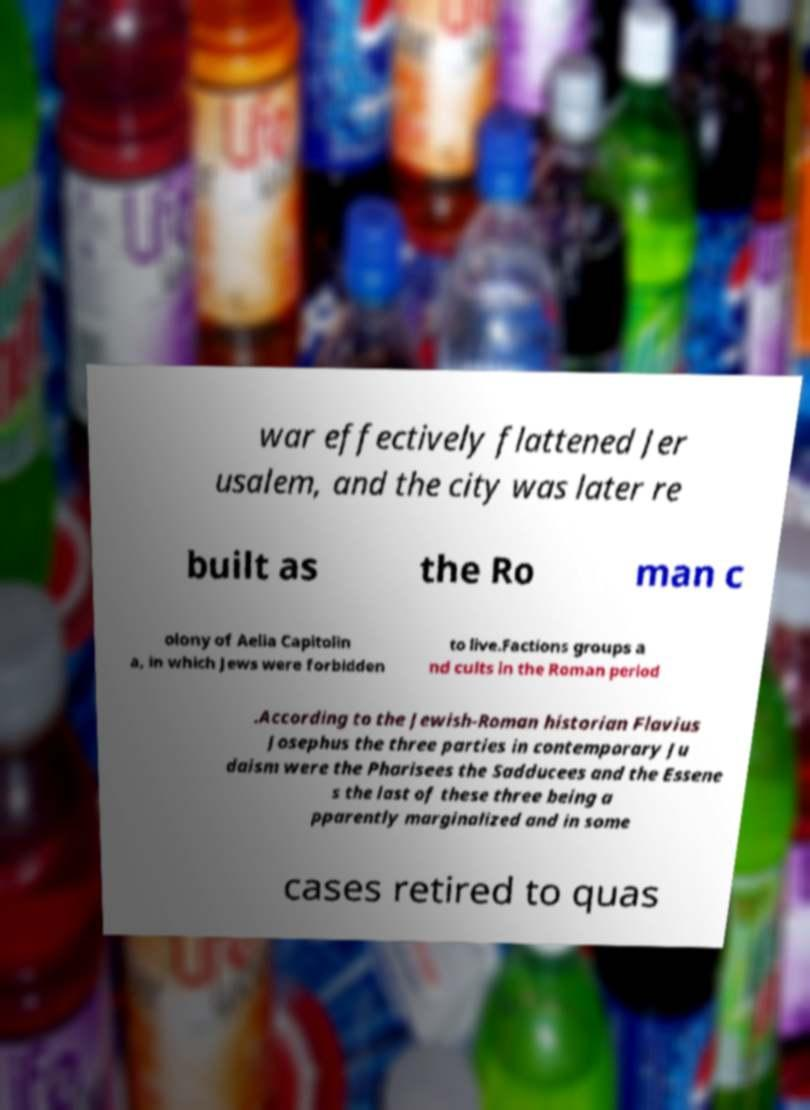Can you read and provide the text displayed in the image?This photo seems to have some interesting text. Can you extract and type it out for me? war effectively flattened Jer usalem, and the city was later re built as the Ro man c olony of Aelia Capitolin a, in which Jews were forbidden to live.Factions groups a nd cults in the Roman period .According to the Jewish-Roman historian Flavius Josephus the three parties in contemporary Ju daism were the Pharisees the Sadducees and the Essene s the last of these three being a pparently marginalized and in some cases retired to quas 